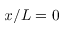Convert formula to latex. <formula><loc_0><loc_0><loc_500><loc_500>x / L = 0</formula> 